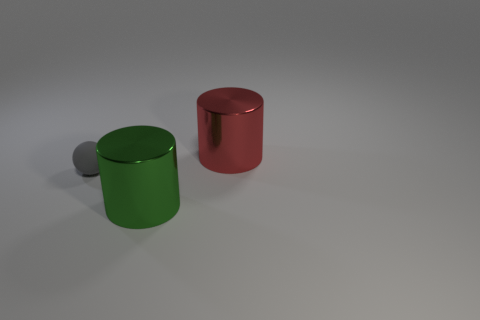Is the number of tiny gray balls that are behind the large red thing the same as the number of tiny things behind the big green metallic thing? Upon examining the image closely, it appears that the quantity of tiny gray spheres located behind the sizable red cylinder is distinct from the number of similar spherical objects positioned behind the large green metallic cylinder. To be more precise, there is one gray sphere behind the red cylinder and two behind the green one. 